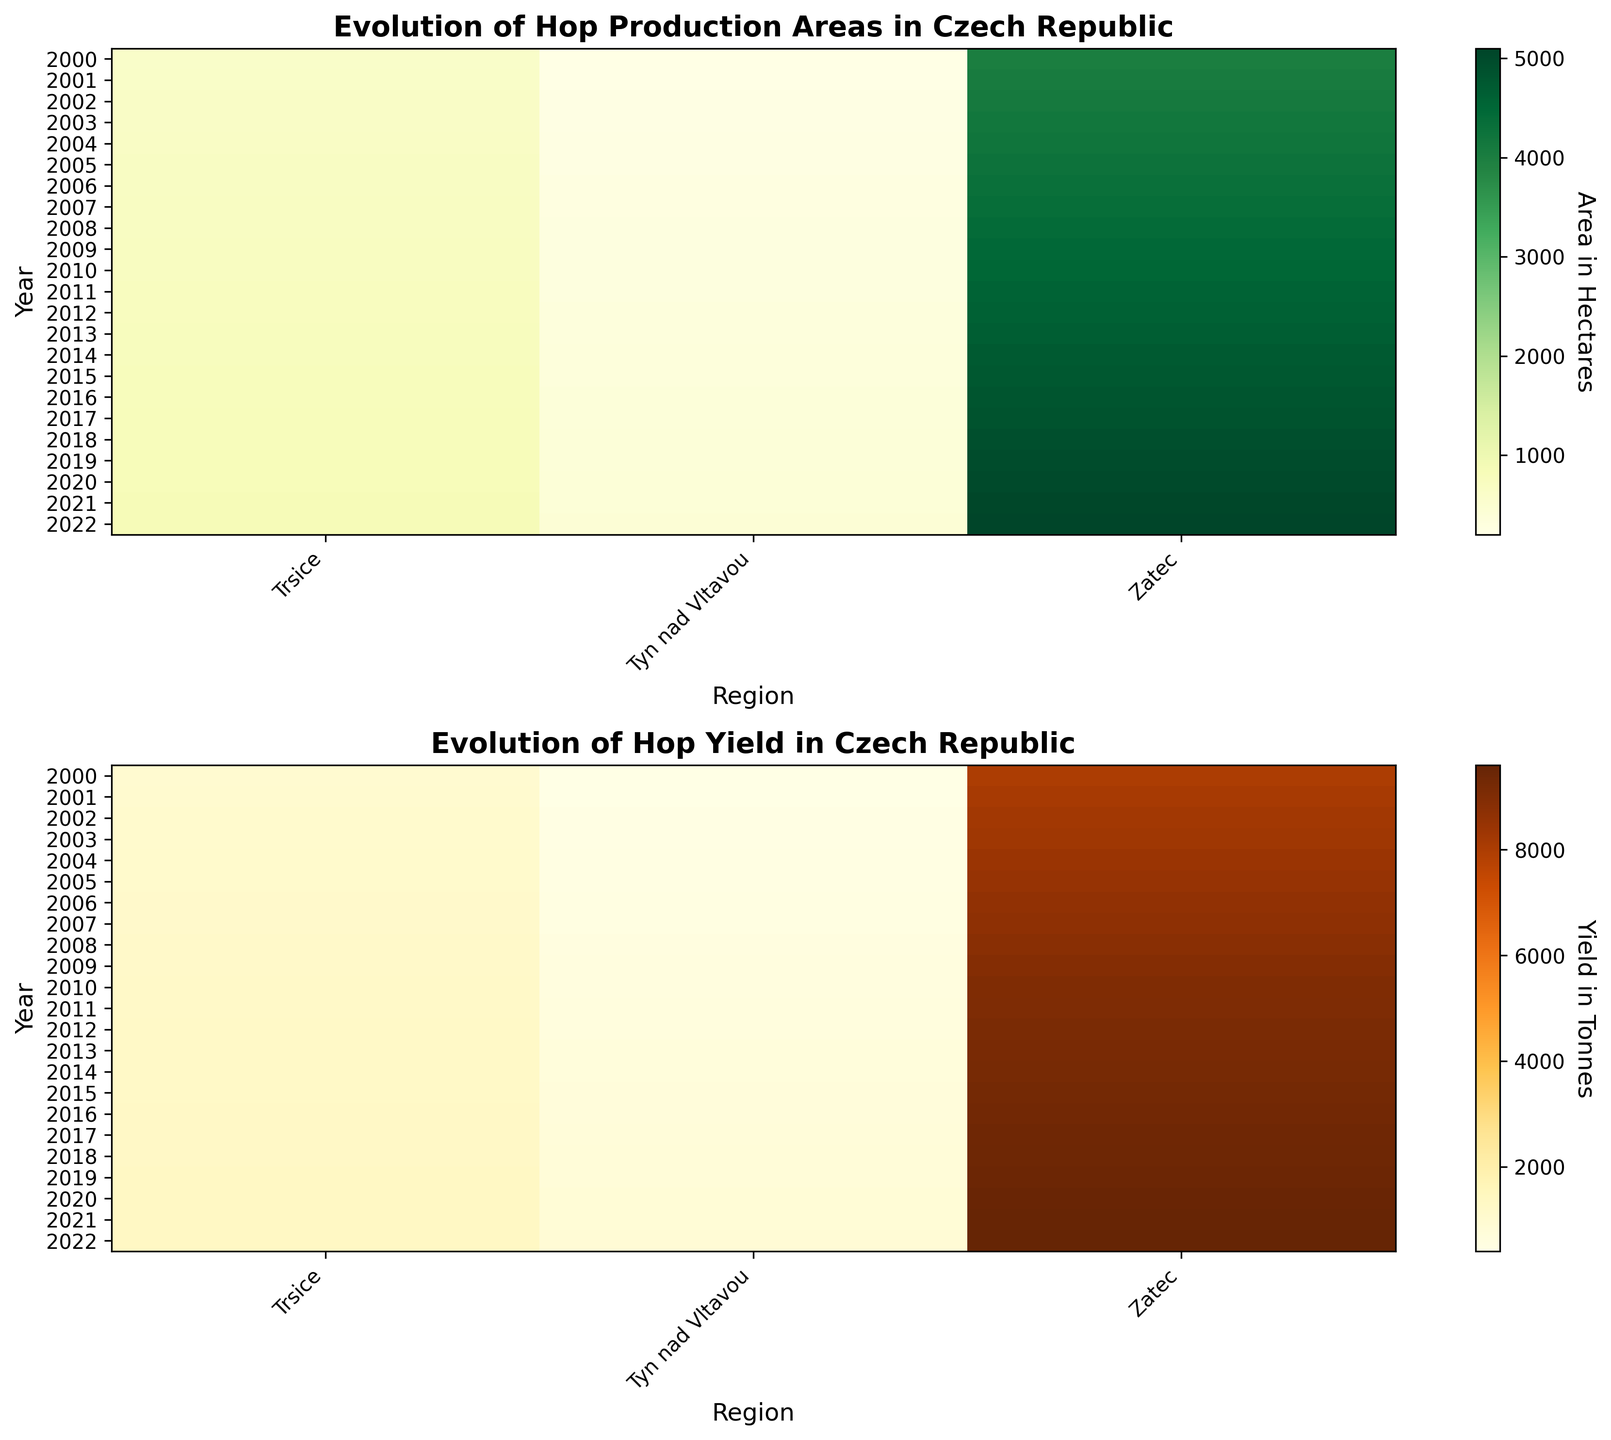Which region had the highest hop production area in 2022? The heatmap visually highlights that the Zatec region had a greater intensity in the area, indicating the largest production area.
Answer: Zatec How did the hop yield in Trsice change from 2000 to 2022? By comparing the color intensity for Trsice in the second heatmap from 2000 to 2022, we can see a steady increase in yield, moving from lighter to darker shades.
Answer: Increased Which year had the lowest hop production area in Tyn nad Vltavou and what was the value? The area heatmap shows the lightest color for Tyn nad Vltavou in 2000, indicating the smallest production area. The value from 2000 corresponding row is 200 hectares.
Answer: 2000, 200 hectares Between which two consecutive years did Zatec see the largest increase in hop production area? By observing the gradient changes in the first heatmap for Zatec, the most noticeable shift occurs between 2004 and 2005. The area increased from 4200 to 4250 hectares.
Answer: 2004 to 2005 What is the total hop production area in 2022 across all regions? Sum the hop production areas from 2022 for Zatec (5100), Trsice (830), and Tyn nad Vltavou (420). Total = 5100 + 830 + 420.
Answer: 6350 hectares Which region had the most consistent hop production area from 2000 to 2022? Examining the consistency in shading along the years, Trsice shows the least variation in color shades compared to Zatec and Tyn nad Vltavou.
Answer: Trsice In which year was the hop yield highest in the Zatec region, and what was the yield? The yield heatmap shows the darkest color for Zatec in 2022, corresponding to the highest yield. The value from the 2022 row for Zatec is 9600 tonnes.
Answer: 2022, 9600 tonnes Which region showed the greatest yield increase from 2005 to 2020? Compare the color changes for each region between 2005 and 2020 in the yield heatmap. The most significant darkening occurs in Trsice, where yield goes from 1110 to 1310 tonnes.
Answer: Trsice What is the average hop yield for Tyn nad Vltavou over the entire period? Add up the yield values for Tyn nad Vltavou from 2000 to 2022 and divide by the number of years (23). Sum = 400+420+440+...+820 = 11060. Average = 11060/23.
Answer: 480 tonnes 